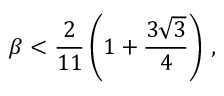Convert formula to latex. <formula><loc_0><loc_0><loc_500><loc_500>\beta < \frac { 2 } { 1 1 } \left ( 1 + \frac { 3 \sqrt { 3 } } { 4 } \right ) \, ,</formula> 